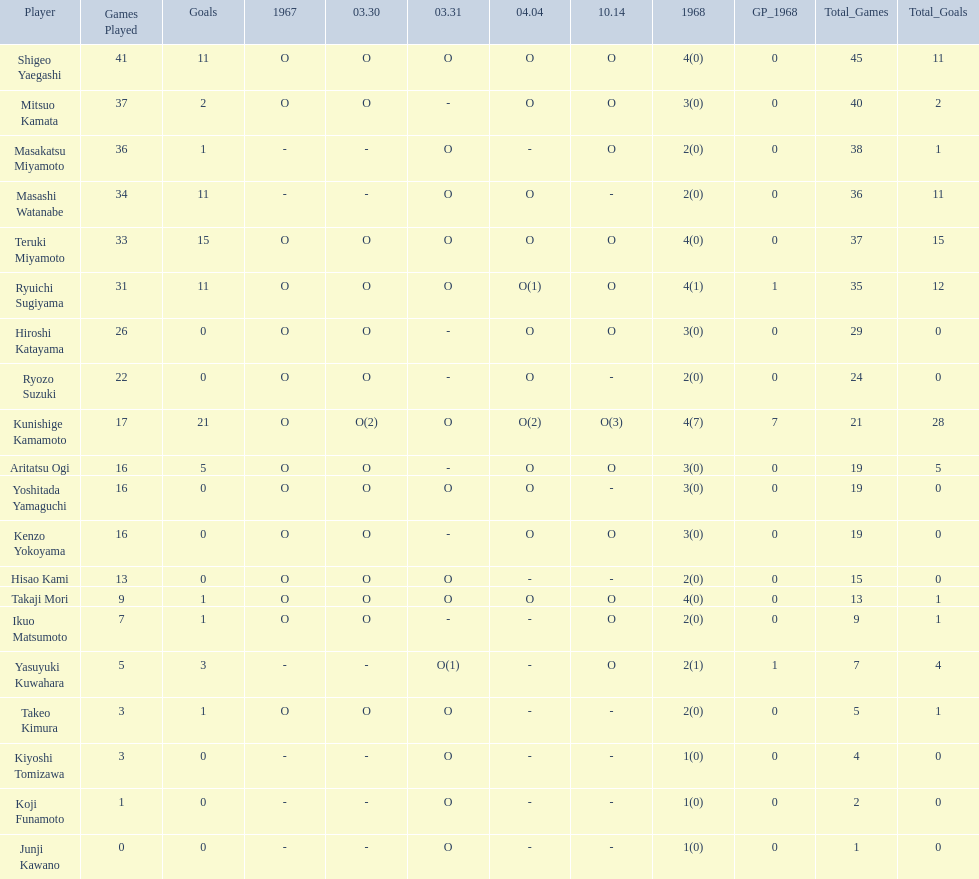How many points did takaji mori have? 13(1). And how many points did junji kawano have? 1(0). To who does the higher of these belong to? Takaji Mori. 